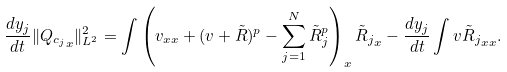<formula> <loc_0><loc_0><loc_500><loc_500>\frac { d y _ { j } } { d t } \| { Q _ { c _ { j } } } _ { x } \| _ { L ^ { 2 } } ^ { 2 } = \int \left ( v _ { x x } + ( v + \tilde { R } ) ^ { p } - \sum _ { j = 1 } ^ { N } \tilde { R } _ { j } ^ { p } \right ) _ { x } { \/ \tilde { R } _ { j } } _ { x } - \frac { d y _ { j } } { d t } \int v { \/ \tilde { R } _ { j } } _ { x x } .</formula> 